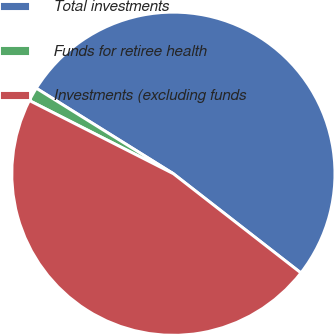Convert chart. <chart><loc_0><loc_0><loc_500><loc_500><pie_chart><fcel>Total investments<fcel>Funds for retiree health<fcel>Investments (excluding funds<nl><fcel>51.65%<fcel>1.39%<fcel>46.96%<nl></chart> 